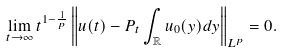<formula> <loc_0><loc_0><loc_500><loc_500>\lim _ { t \to \infty } t ^ { 1 - \frac { 1 } { p } } \left \| u ( t ) - P _ { t } \int _ { \mathbb { R } } u _ { 0 } ( y ) d y \right \| _ { L ^ { p } } = 0 .</formula> 